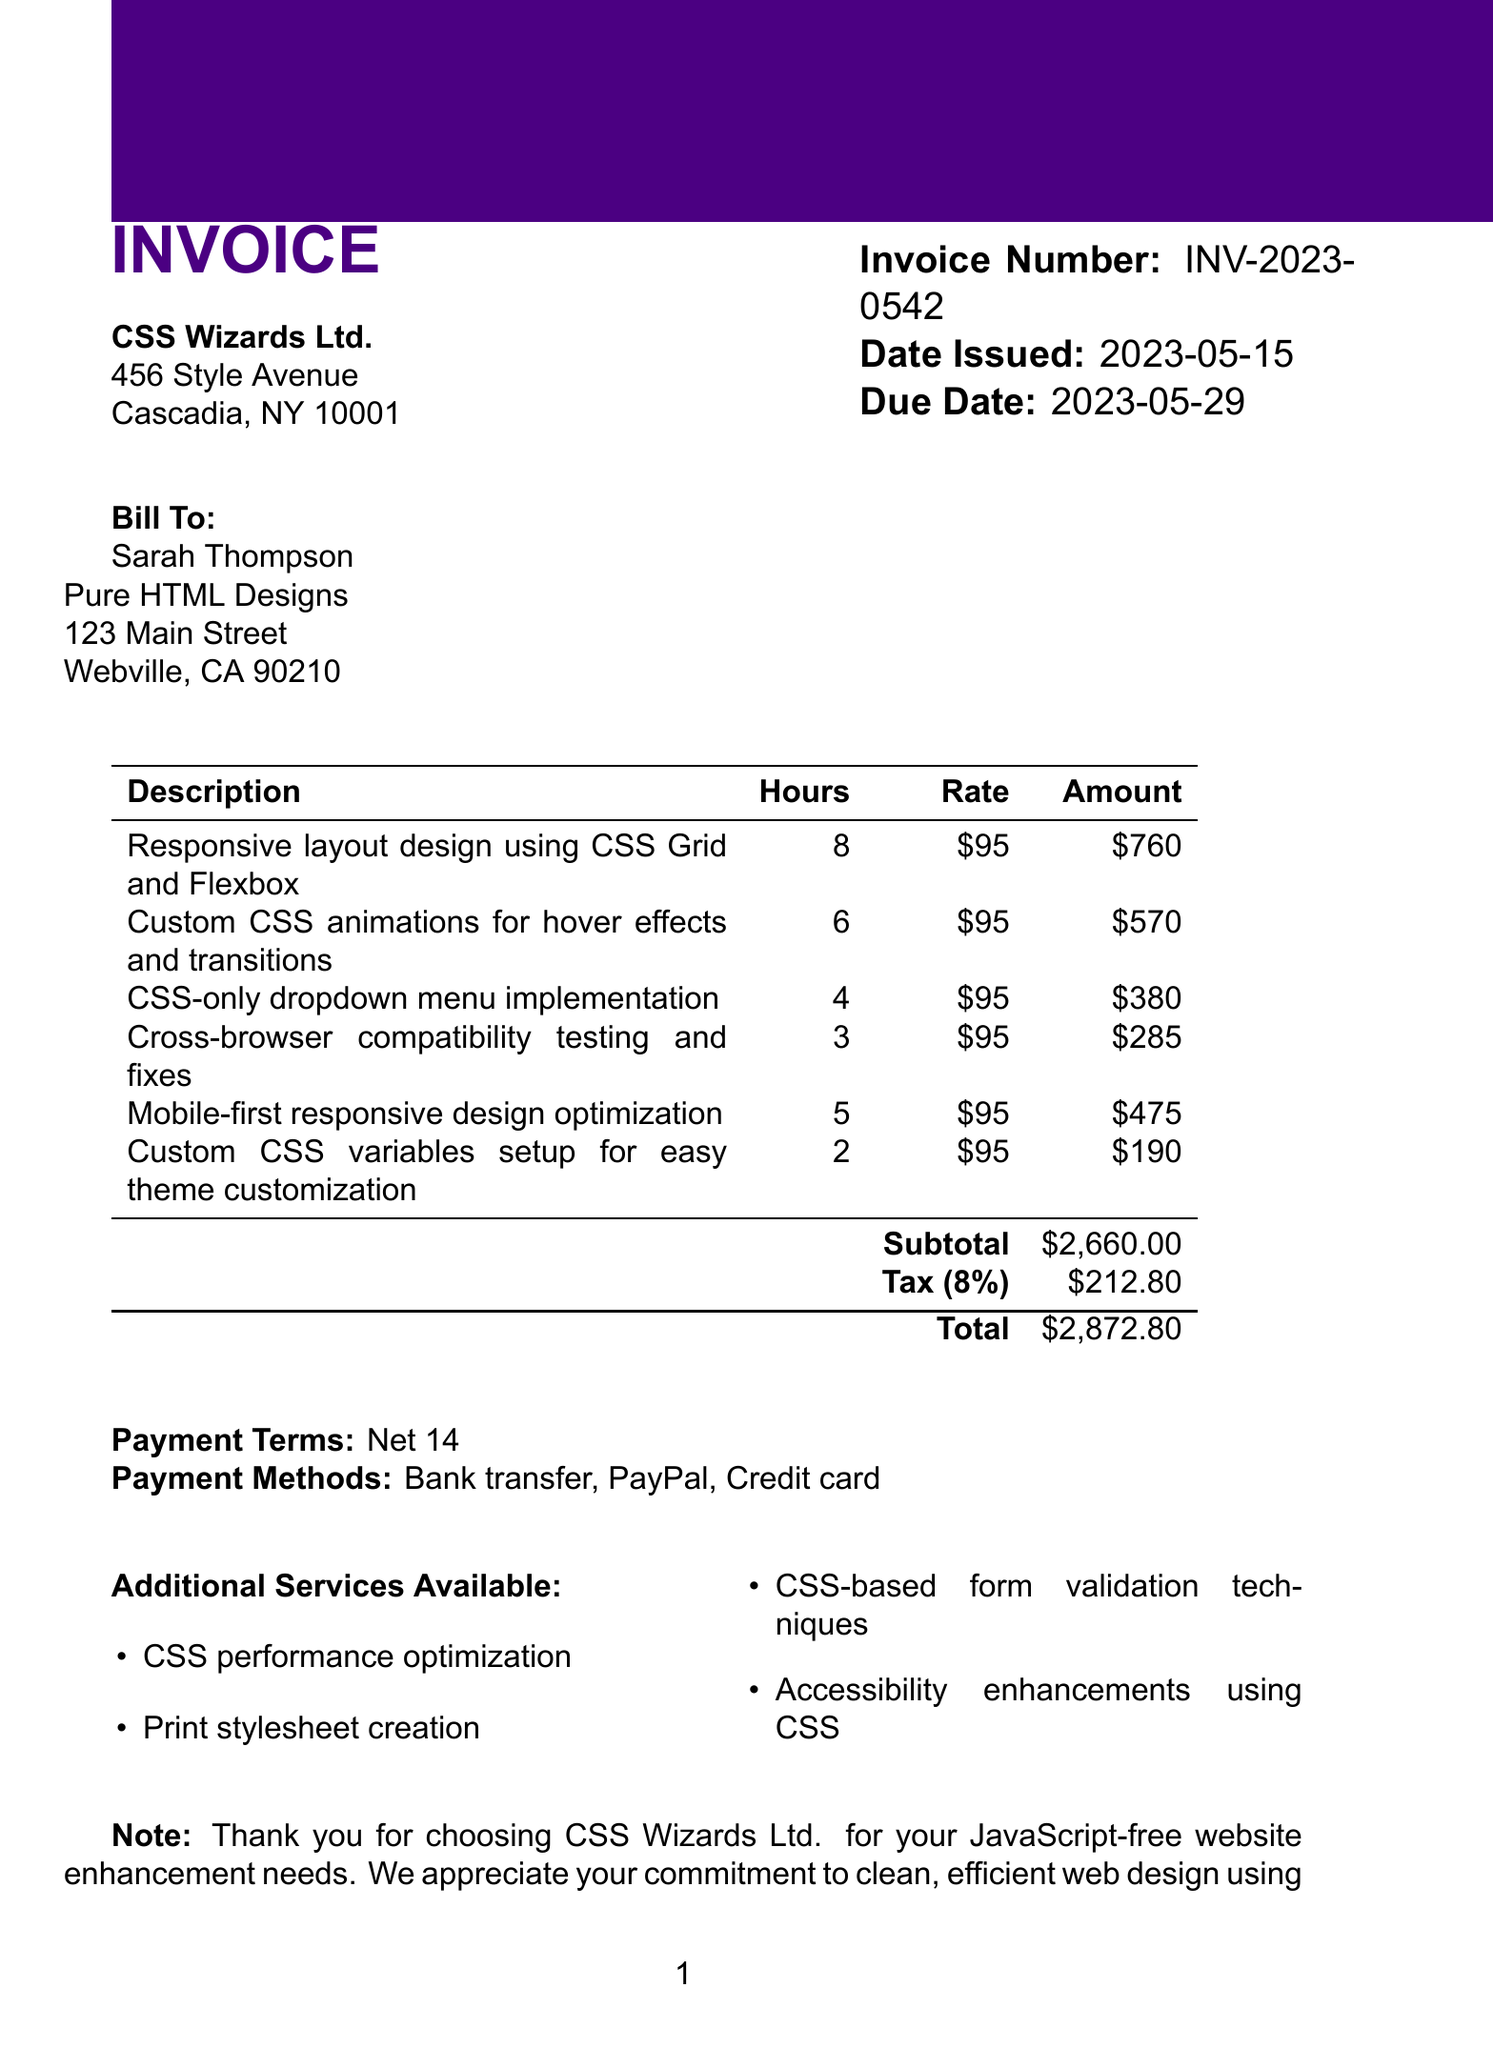What is the invoice number? The invoice number is a unique identifier for this transaction.
Answer: INV-2023-0542 What is the due date for the invoice? The due date indicates when payment should be received.
Answer: 2023-05-29 Who is the client? The client is the individual or company receiving the services rendered.
Answer: Sarah Thompson What is the subtotal amount before tax? The subtotal represents the total before any taxes are added.
Answer: 2660 How many hours were spent on the CSS-only dropdown menu? The hours reflect the time devoted to that specific service.
Answer: 4 What service was performed for mobile-first optimization? This describes a specific service provided as detailed in the document.
Answer: Mobile-first responsive design optimization What is the tax rate applied to the invoice? The tax rate is the percentage charged on the subtotal for tax calculation.
Answer: 8% Which payment method is NOT listed? This question considers available payment options mentioned in the document.
Answer: Cash What additional service focuses on visual performance? This refers to enhancements that improve website loading and rendering.
Answer: CSS performance optimization How much is the total amount due? The total amount includes the subtotal along with tax and represents the final payment.
Answer: 2872.80 